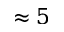Convert formula to latex. <formula><loc_0><loc_0><loc_500><loc_500>\approx 5</formula> 